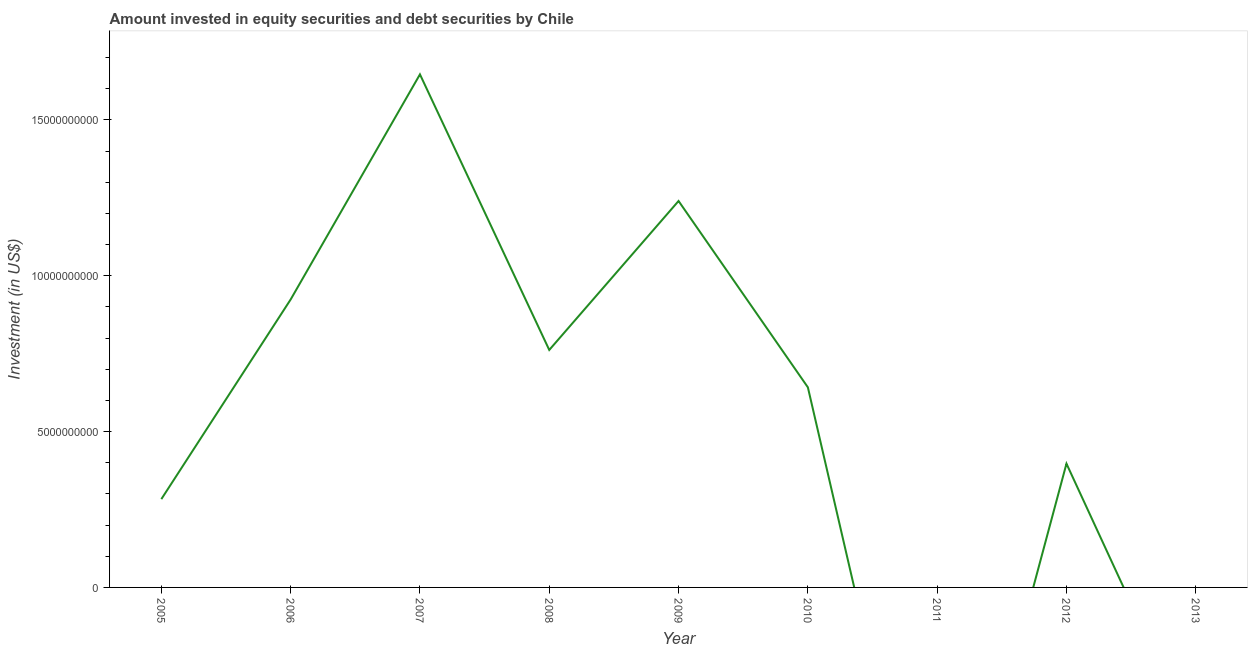What is the portfolio investment in 2008?
Provide a short and direct response. 7.62e+09. Across all years, what is the maximum portfolio investment?
Your response must be concise. 1.65e+1. What is the sum of the portfolio investment?
Your response must be concise. 5.89e+1. What is the difference between the portfolio investment in 2008 and 2009?
Your answer should be very brief. -4.78e+09. What is the average portfolio investment per year?
Provide a succinct answer. 6.55e+09. What is the median portfolio investment?
Offer a very short reply. 6.42e+09. In how many years, is the portfolio investment greater than 9000000000 US$?
Keep it short and to the point. 3. What is the ratio of the portfolio investment in 2005 to that in 2010?
Ensure brevity in your answer.  0.44. Is the portfolio investment in 2005 less than that in 2007?
Make the answer very short. Yes. Is the difference between the portfolio investment in 2005 and 2012 greater than the difference between any two years?
Your answer should be very brief. No. What is the difference between the highest and the second highest portfolio investment?
Make the answer very short. 4.06e+09. What is the difference between the highest and the lowest portfolio investment?
Provide a succinct answer. 1.65e+1. Does the portfolio investment monotonically increase over the years?
Provide a short and direct response. No. How many years are there in the graph?
Make the answer very short. 9. Are the values on the major ticks of Y-axis written in scientific E-notation?
Offer a terse response. No. Does the graph contain grids?
Offer a very short reply. No. What is the title of the graph?
Offer a very short reply. Amount invested in equity securities and debt securities by Chile. What is the label or title of the X-axis?
Make the answer very short. Year. What is the label or title of the Y-axis?
Provide a succinct answer. Investment (in US$). What is the Investment (in US$) of 2005?
Your response must be concise. 2.83e+09. What is the Investment (in US$) of 2006?
Ensure brevity in your answer.  9.24e+09. What is the Investment (in US$) of 2007?
Your response must be concise. 1.65e+1. What is the Investment (in US$) of 2008?
Offer a very short reply. 7.62e+09. What is the Investment (in US$) in 2009?
Provide a succinct answer. 1.24e+1. What is the Investment (in US$) of 2010?
Give a very brief answer. 6.42e+09. What is the Investment (in US$) in 2011?
Ensure brevity in your answer.  0. What is the Investment (in US$) of 2012?
Provide a succinct answer. 3.97e+09. What is the Investment (in US$) of 2013?
Offer a very short reply. 0. What is the difference between the Investment (in US$) in 2005 and 2006?
Make the answer very short. -6.41e+09. What is the difference between the Investment (in US$) in 2005 and 2007?
Keep it short and to the point. -1.36e+1. What is the difference between the Investment (in US$) in 2005 and 2008?
Your answer should be compact. -4.79e+09. What is the difference between the Investment (in US$) in 2005 and 2009?
Provide a short and direct response. -9.57e+09. What is the difference between the Investment (in US$) in 2005 and 2010?
Keep it short and to the point. -3.59e+09. What is the difference between the Investment (in US$) in 2005 and 2012?
Your response must be concise. -1.14e+09. What is the difference between the Investment (in US$) in 2006 and 2007?
Provide a short and direct response. -7.22e+09. What is the difference between the Investment (in US$) in 2006 and 2008?
Offer a very short reply. 1.62e+09. What is the difference between the Investment (in US$) in 2006 and 2009?
Your answer should be very brief. -3.16e+09. What is the difference between the Investment (in US$) in 2006 and 2010?
Offer a terse response. 2.82e+09. What is the difference between the Investment (in US$) in 2006 and 2012?
Provide a short and direct response. 5.27e+09. What is the difference between the Investment (in US$) in 2007 and 2008?
Ensure brevity in your answer.  8.84e+09. What is the difference between the Investment (in US$) in 2007 and 2009?
Your answer should be compact. 4.06e+09. What is the difference between the Investment (in US$) in 2007 and 2010?
Keep it short and to the point. 1.00e+1. What is the difference between the Investment (in US$) in 2007 and 2012?
Offer a very short reply. 1.25e+1. What is the difference between the Investment (in US$) in 2008 and 2009?
Provide a short and direct response. -4.78e+09. What is the difference between the Investment (in US$) in 2008 and 2010?
Ensure brevity in your answer.  1.20e+09. What is the difference between the Investment (in US$) in 2008 and 2012?
Offer a terse response. 3.65e+09. What is the difference between the Investment (in US$) in 2009 and 2010?
Your answer should be compact. 5.98e+09. What is the difference between the Investment (in US$) in 2009 and 2012?
Offer a very short reply. 8.43e+09. What is the difference between the Investment (in US$) in 2010 and 2012?
Keep it short and to the point. 2.45e+09. What is the ratio of the Investment (in US$) in 2005 to that in 2006?
Provide a succinct answer. 0.31. What is the ratio of the Investment (in US$) in 2005 to that in 2007?
Give a very brief answer. 0.17. What is the ratio of the Investment (in US$) in 2005 to that in 2008?
Your answer should be very brief. 0.37. What is the ratio of the Investment (in US$) in 2005 to that in 2009?
Give a very brief answer. 0.23. What is the ratio of the Investment (in US$) in 2005 to that in 2010?
Ensure brevity in your answer.  0.44. What is the ratio of the Investment (in US$) in 2005 to that in 2012?
Provide a succinct answer. 0.71. What is the ratio of the Investment (in US$) in 2006 to that in 2007?
Make the answer very short. 0.56. What is the ratio of the Investment (in US$) in 2006 to that in 2008?
Provide a short and direct response. 1.21. What is the ratio of the Investment (in US$) in 2006 to that in 2009?
Offer a very short reply. 0.74. What is the ratio of the Investment (in US$) in 2006 to that in 2010?
Your response must be concise. 1.44. What is the ratio of the Investment (in US$) in 2006 to that in 2012?
Ensure brevity in your answer.  2.33. What is the ratio of the Investment (in US$) in 2007 to that in 2008?
Provide a succinct answer. 2.16. What is the ratio of the Investment (in US$) in 2007 to that in 2009?
Provide a succinct answer. 1.33. What is the ratio of the Investment (in US$) in 2007 to that in 2010?
Your response must be concise. 2.56. What is the ratio of the Investment (in US$) in 2007 to that in 2012?
Ensure brevity in your answer.  4.14. What is the ratio of the Investment (in US$) in 2008 to that in 2009?
Make the answer very short. 0.61. What is the ratio of the Investment (in US$) in 2008 to that in 2010?
Offer a very short reply. 1.19. What is the ratio of the Investment (in US$) in 2008 to that in 2012?
Ensure brevity in your answer.  1.92. What is the ratio of the Investment (in US$) in 2009 to that in 2010?
Offer a very short reply. 1.93. What is the ratio of the Investment (in US$) in 2009 to that in 2012?
Your response must be concise. 3.12. What is the ratio of the Investment (in US$) in 2010 to that in 2012?
Offer a terse response. 1.62. 